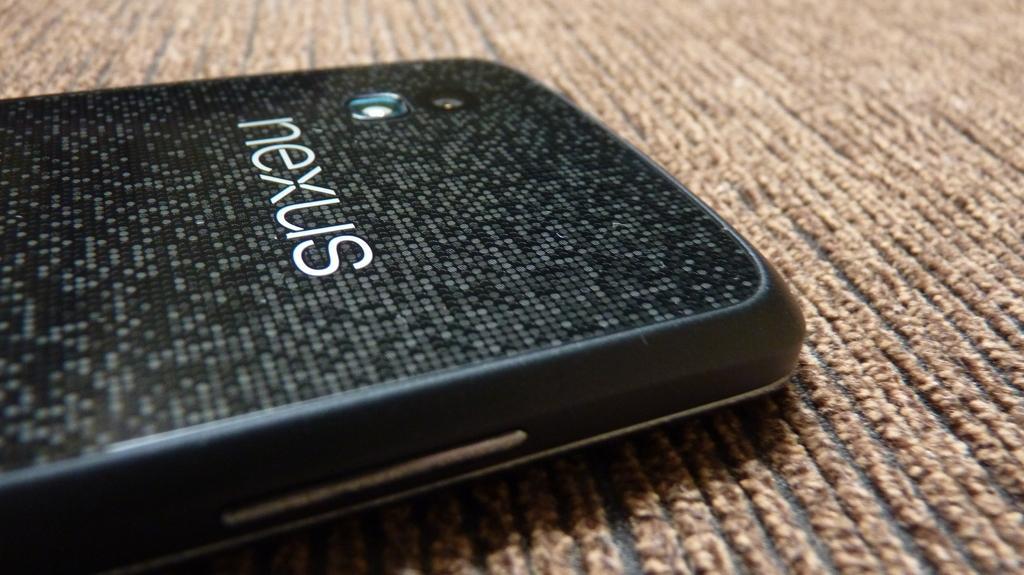Can you describe this image briefly? In this image, I can see a mobile phone, which is placed on the floor. I can see the name and a camera on the mobile phone. I think these are the buttons. 